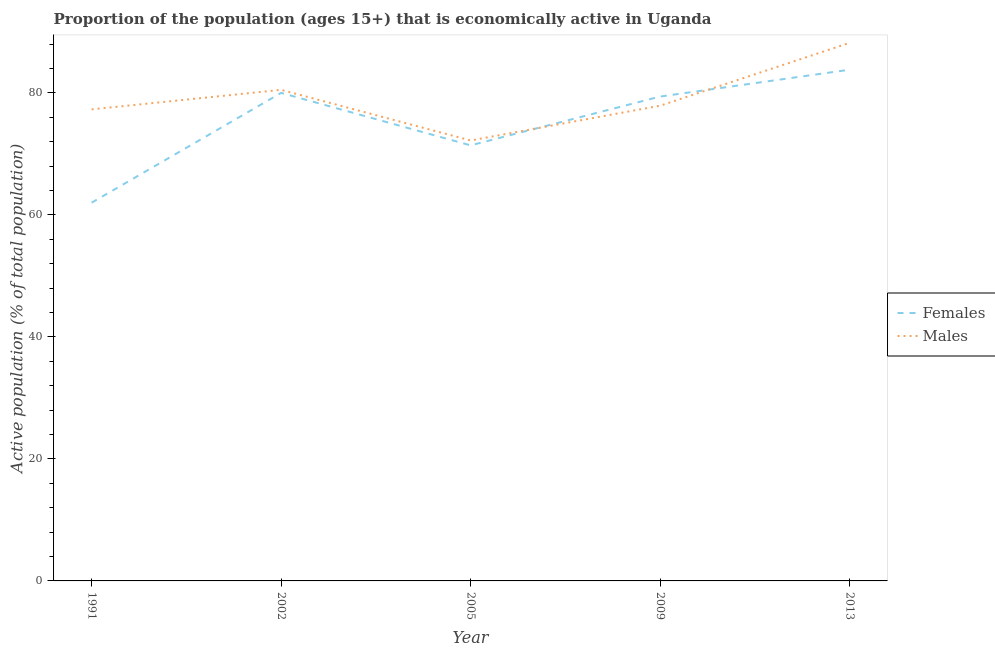Does the line corresponding to percentage of economically active female population intersect with the line corresponding to percentage of economically active male population?
Offer a very short reply. Yes. What is the percentage of economically active female population in 2013?
Your answer should be compact. 83.8. Across all years, what is the maximum percentage of economically active female population?
Offer a very short reply. 83.8. Across all years, what is the minimum percentage of economically active male population?
Offer a very short reply. 72.2. In which year was the percentage of economically active male population minimum?
Give a very brief answer. 2005. What is the total percentage of economically active male population in the graph?
Ensure brevity in your answer.  396.1. What is the difference between the percentage of economically active female population in 2002 and that in 2013?
Your answer should be compact. -3.8. What is the difference between the percentage of economically active female population in 2005 and the percentage of economically active male population in 2013?
Provide a succinct answer. -16.8. What is the average percentage of economically active male population per year?
Offer a terse response. 79.22. In the year 2013, what is the difference between the percentage of economically active female population and percentage of economically active male population?
Keep it short and to the point. -4.4. In how many years, is the percentage of economically active female population greater than 36 %?
Your response must be concise. 5. What is the ratio of the percentage of economically active male population in 2002 to that in 2013?
Your response must be concise. 0.91. What is the difference between the highest and the second highest percentage of economically active female population?
Your response must be concise. 3.8. Is the sum of the percentage of economically active female population in 1991 and 2009 greater than the maximum percentage of economically active male population across all years?
Ensure brevity in your answer.  Yes. Are the values on the major ticks of Y-axis written in scientific E-notation?
Keep it short and to the point. No. Does the graph contain any zero values?
Ensure brevity in your answer.  No. Where does the legend appear in the graph?
Provide a succinct answer. Center right. How many legend labels are there?
Give a very brief answer. 2. How are the legend labels stacked?
Your response must be concise. Vertical. What is the title of the graph?
Provide a succinct answer. Proportion of the population (ages 15+) that is economically active in Uganda. What is the label or title of the X-axis?
Provide a short and direct response. Year. What is the label or title of the Y-axis?
Keep it short and to the point. Active population (% of total population). What is the Active population (% of total population) of Males in 1991?
Give a very brief answer. 77.3. What is the Active population (% of total population) of Males in 2002?
Provide a succinct answer. 80.5. What is the Active population (% of total population) in Females in 2005?
Offer a terse response. 71.4. What is the Active population (% of total population) in Males in 2005?
Provide a short and direct response. 72.2. What is the Active population (% of total population) of Females in 2009?
Your response must be concise. 79.4. What is the Active population (% of total population) of Males in 2009?
Your response must be concise. 77.9. What is the Active population (% of total population) of Females in 2013?
Keep it short and to the point. 83.8. What is the Active population (% of total population) in Males in 2013?
Your answer should be compact. 88.2. Across all years, what is the maximum Active population (% of total population) in Females?
Your response must be concise. 83.8. Across all years, what is the maximum Active population (% of total population) of Males?
Give a very brief answer. 88.2. Across all years, what is the minimum Active population (% of total population) of Males?
Your answer should be very brief. 72.2. What is the total Active population (% of total population) of Females in the graph?
Your answer should be very brief. 376.6. What is the total Active population (% of total population) of Males in the graph?
Your response must be concise. 396.1. What is the difference between the Active population (% of total population) of Males in 1991 and that in 2002?
Your response must be concise. -3.2. What is the difference between the Active population (% of total population) of Males in 1991 and that in 2005?
Your answer should be very brief. 5.1. What is the difference between the Active population (% of total population) of Females in 1991 and that in 2009?
Provide a succinct answer. -17.4. What is the difference between the Active population (% of total population) of Females in 1991 and that in 2013?
Provide a succinct answer. -21.8. What is the difference between the Active population (% of total population) in Females in 2002 and that in 2005?
Offer a very short reply. 8.6. What is the difference between the Active population (% of total population) of Females in 2002 and that in 2009?
Your response must be concise. 0.6. What is the difference between the Active population (% of total population) of Females in 2002 and that in 2013?
Provide a short and direct response. -3.8. What is the difference between the Active population (% of total population) in Males in 2002 and that in 2013?
Your response must be concise. -7.7. What is the difference between the Active population (% of total population) of Females in 2005 and that in 2009?
Your answer should be compact. -8. What is the difference between the Active population (% of total population) of Females in 2009 and that in 2013?
Ensure brevity in your answer.  -4.4. What is the difference between the Active population (% of total population) of Females in 1991 and the Active population (% of total population) of Males in 2002?
Ensure brevity in your answer.  -18.5. What is the difference between the Active population (% of total population) in Females in 1991 and the Active population (% of total population) in Males in 2005?
Offer a terse response. -10.2. What is the difference between the Active population (% of total population) of Females in 1991 and the Active population (% of total population) of Males in 2009?
Offer a very short reply. -15.9. What is the difference between the Active population (% of total population) in Females in 1991 and the Active population (% of total population) in Males in 2013?
Provide a short and direct response. -26.2. What is the difference between the Active population (% of total population) of Females in 2002 and the Active population (% of total population) of Males in 2005?
Offer a very short reply. 7.8. What is the difference between the Active population (% of total population) of Females in 2002 and the Active population (% of total population) of Males in 2009?
Your answer should be very brief. 2.1. What is the difference between the Active population (% of total population) of Females in 2005 and the Active population (% of total population) of Males in 2009?
Keep it short and to the point. -6.5. What is the difference between the Active population (% of total population) of Females in 2005 and the Active population (% of total population) of Males in 2013?
Offer a terse response. -16.8. What is the difference between the Active population (% of total population) of Females in 2009 and the Active population (% of total population) of Males in 2013?
Offer a very short reply. -8.8. What is the average Active population (% of total population) in Females per year?
Your answer should be very brief. 75.32. What is the average Active population (% of total population) in Males per year?
Ensure brevity in your answer.  79.22. In the year 1991, what is the difference between the Active population (% of total population) in Females and Active population (% of total population) in Males?
Offer a terse response. -15.3. In the year 2002, what is the difference between the Active population (% of total population) of Females and Active population (% of total population) of Males?
Keep it short and to the point. -0.5. In the year 2005, what is the difference between the Active population (% of total population) of Females and Active population (% of total population) of Males?
Provide a succinct answer. -0.8. In the year 2009, what is the difference between the Active population (% of total population) of Females and Active population (% of total population) of Males?
Your response must be concise. 1.5. In the year 2013, what is the difference between the Active population (% of total population) in Females and Active population (% of total population) in Males?
Your response must be concise. -4.4. What is the ratio of the Active population (% of total population) in Females in 1991 to that in 2002?
Offer a very short reply. 0.78. What is the ratio of the Active population (% of total population) of Males in 1991 to that in 2002?
Your answer should be very brief. 0.96. What is the ratio of the Active population (% of total population) of Females in 1991 to that in 2005?
Make the answer very short. 0.87. What is the ratio of the Active population (% of total population) in Males in 1991 to that in 2005?
Your response must be concise. 1.07. What is the ratio of the Active population (% of total population) of Females in 1991 to that in 2009?
Give a very brief answer. 0.78. What is the ratio of the Active population (% of total population) of Females in 1991 to that in 2013?
Provide a short and direct response. 0.74. What is the ratio of the Active population (% of total population) in Males in 1991 to that in 2013?
Ensure brevity in your answer.  0.88. What is the ratio of the Active population (% of total population) of Females in 2002 to that in 2005?
Offer a terse response. 1.12. What is the ratio of the Active population (% of total population) of Males in 2002 to that in 2005?
Provide a short and direct response. 1.11. What is the ratio of the Active population (% of total population) of Females in 2002 to that in 2009?
Your answer should be compact. 1.01. What is the ratio of the Active population (% of total population) of Males in 2002 to that in 2009?
Give a very brief answer. 1.03. What is the ratio of the Active population (% of total population) of Females in 2002 to that in 2013?
Provide a short and direct response. 0.95. What is the ratio of the Active population (% of total population) in Males in 2002 to that in 2013?
Give a very brief answer. 0.91. What is the ratio of the Active population (% of total population) of Females in 2005 to that in 2009?
Your answer should be compact. 0.9. What is the ratio of the Active population (% of total population) of Males in 2005 to that in 2009?
Provide a succinct answer. 0.93. What is the ratio of the Active population (% of total population) of Females in 2005 to that in 2013?
Offer a very short reply. 0.85. What is the ratio of the Active population (% of total population) in Males in 2005 to that in 2013?
Provide a short and direct response. 0.82. What is the ratio of the Active population (% of total population) in Females in 2009 to that in 2013?
Your response must be concise. 0.95. What is the ratio of the Active population (% of total population) in Males in 2009 to that in 2013?
Make the answer very short. 0.88. What is the difference between the highest and the second highest Active population (% of total population) in Females?
Your answer should be very brief. 3.8. What is the difference between the highest and the lowest Active population (% of total population) in Females?
Make the answer very short. 21.8. 